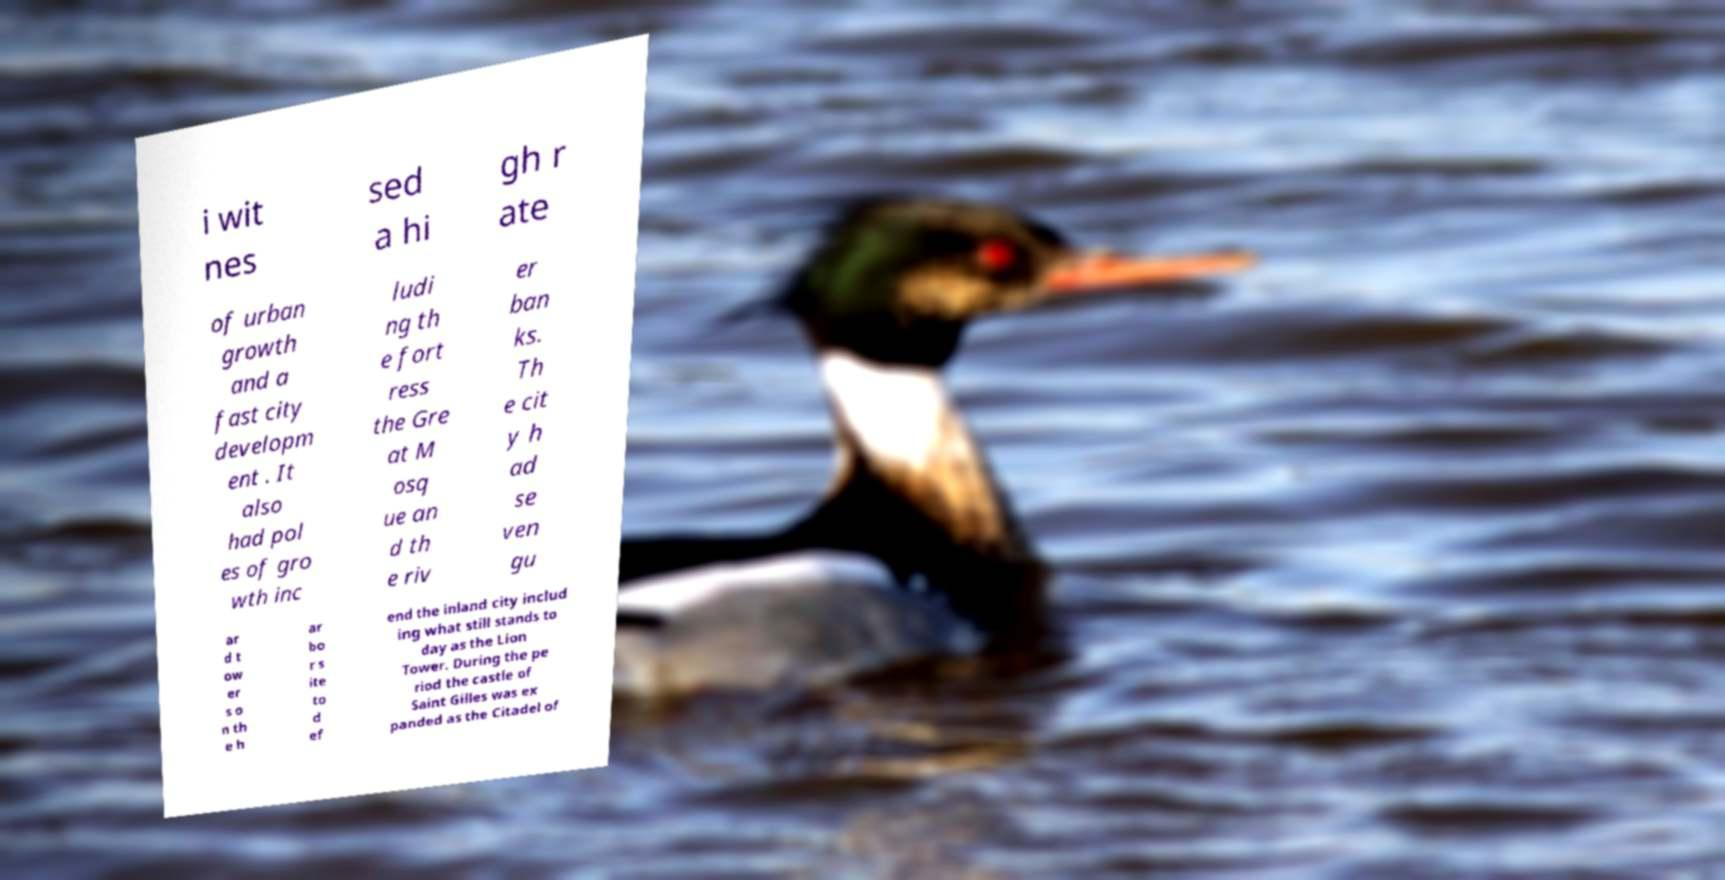For documentation purposes, I need the text within this image transcribed. Could you provide that? i wit nes sed a hi gh r ate of urban growth and a fast city developm ent . It also had pol es of gro wth inc ludi ng th e fort ress the Gre at M osq ue an d th e riv er ban ks. Th e cit y h ad se ven gu ar d t ow er s o n th e h ar bo r s ite to d ef end the inland city includ ing what still stands to day as the Lion Tower. During the pe riod the castle of Saint Gilles was ex panded as the Citadel of 